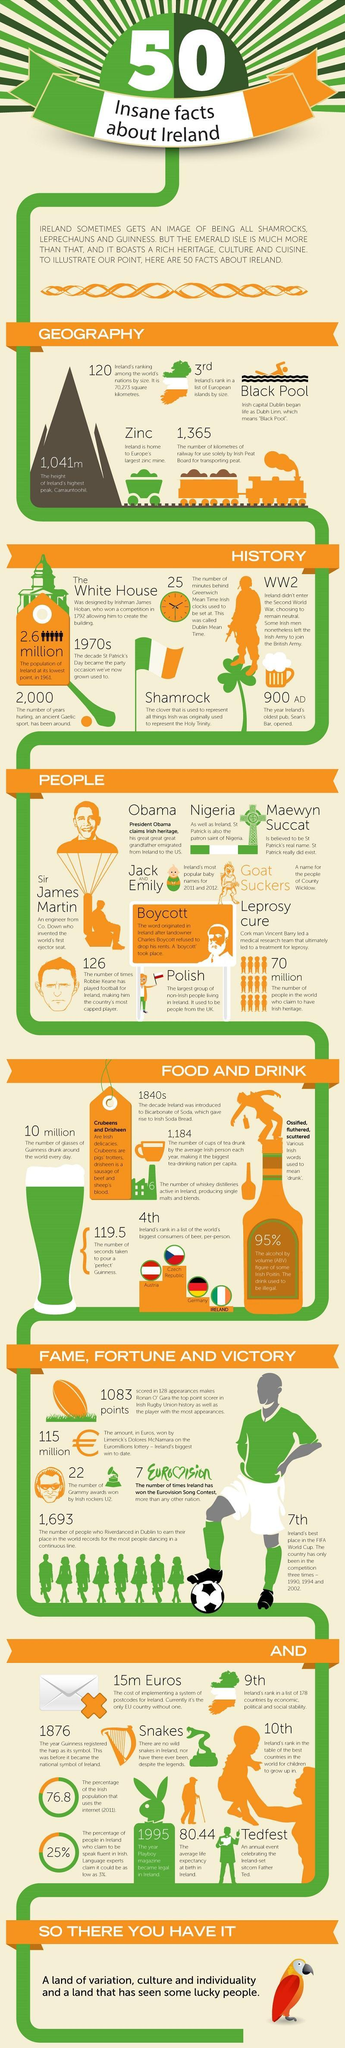What is the name given for people of County Wicklow?
Answer the question with a short phrase. Goat Suckers What percentage of the irish population do not use the internet in 2011? 23.2% What is the no of people in the world who claim to have Irish heritage? 70 million What is the height of Ireland's highest peak? 1,041 m Which country in Europe has the  largest zinc mine? Ireland Which is the Ireland's most popular baby names for 2011 & 2012? JACK AND EMILY What is Ireland's rank in a list of the world's biggest consumers of beer per person? 4 th Which type of reptiles are not found on the island of Ireland? Snakes Which is the highest mountain on the island of Ireland? carrauntoohil In which year is the Ireland's oldest pub, Sean's Bar, opened? 900 AD 